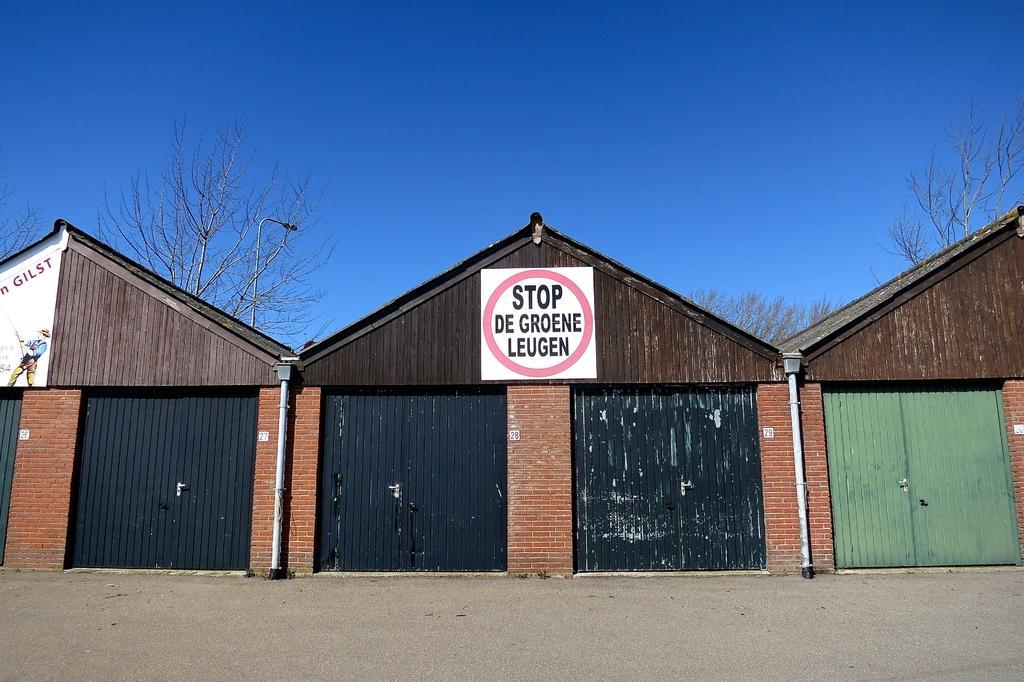In one or two sentences, can you explain what this image depicts? In the center of the picture there are trees, street light and buildings. In the foreground it is land. In the background we can see sky. 